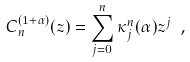Convert formula to latex. <formula><loc_0><loc_0><loc_500><loc_500>C ^ { ( 1 + \alpha ) } _ { n } ( z ) = \sum _ { j = 0 } ^ { n } \kappa ^ { n } _ { j } ( \alpha ) z ^ { j } \ ,</formula> 